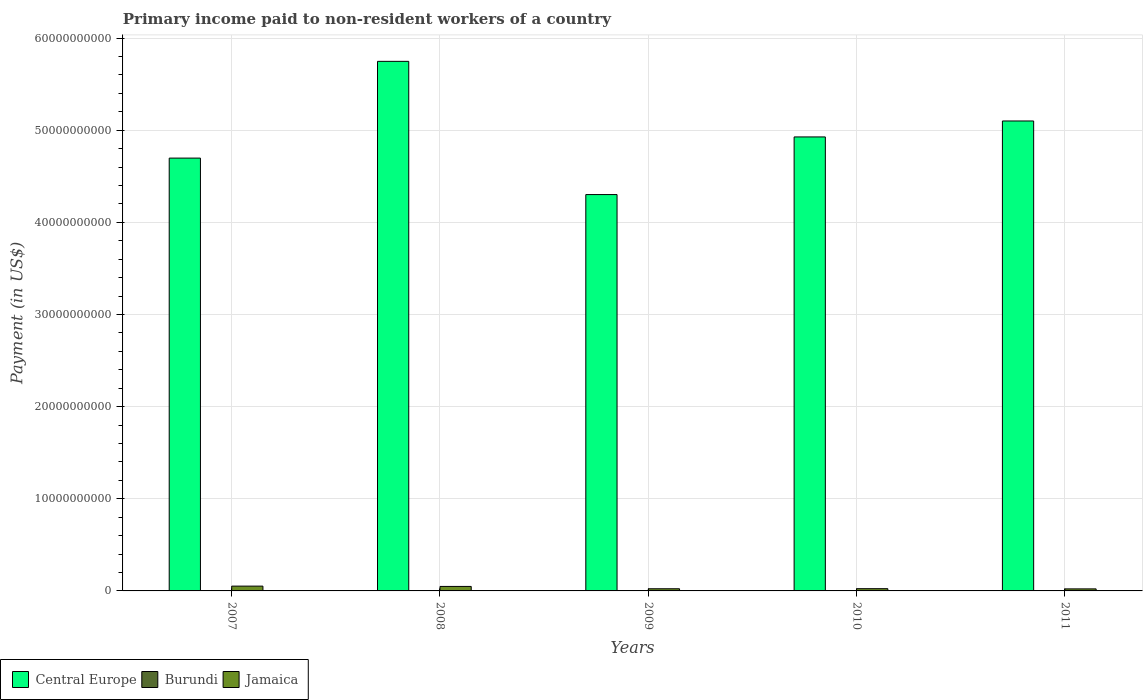How many different coloured bars are there?
Make the answer very short. 3. How many groups of bars are there?
Give a very brief answer. 5. Are the number of bars per tick equal to the number of legend labels?
Offer a terse response. Yes. Are the number of bars on each tick of the X-axis equal?
Your response must be concise. Yes. How many bars are there on the 5th tick from the left?
Offer a very short reply. 3. How many bars are there on the 4th tick from the right?
Give a very brief answer. 3. What is the amount paid to workers in Jamaica in 2010?
Ensure brevity in your answer.  2.43e+08. Across all years, what is the maximum amount paid to workers in Burundi?
Provide a succinct answer. 1.09e+07. Across all years, what is the minimum amount paid to workers in Central Europe?
Offer a terse response. 4.30e+1. What is the total amount paid to workers in Central Europe in the graph?
Offer a very short reply. 2.48e+11. What is the difference between the amount paid to workers in Jamaica in 2007 and that in 2011?
Keep it short and to the point. 2.99e+08. What is the difference between the amount paid to workers in Central Europe in 2007 and the amount paid to workers in Jamaica in 2009?
Keep it short and to the point. 4.67e+1. What is the average amount paid to workers in Burundi per year?
Give a very brief answer. 5.90e+06. In the year 2007, what is the difference between the amount paid to workers in Jamaica and amount paid to workers in Burundi?
Make the answer very short. 5.12e+08. In how many years, is the amount paid to workers in Jamaica greater than 22000000000 US$?
Your response must be concise. 0. What is the ratio of the amount paid to workers in Burundi in 2007 to that in 2011?
Ensure brevity in your answer.  1.16. Is the amount paid to workers in Central Europe in 2007 less than that in 2009?
Offer a very short reply. No. What is the difference between the highest and the second highest amount paid to workers in Jamaica?
Your answer should be compact. 3.28e+07. What is the difference between the highest and the lowest amount paid to workers in Central Europe?
Your answer should be compact. 1.45e+1. Is the sum of the amount paid to workers in Burundi in 2008 and 2009 greater than the maximum amount paid to workers in Central Europe across all years?
Offer a terse response. No. What does the 3rd bar from the left in 2011 represents?
Your answer should be compact. Jamaica. What does the 2nd bar from the right in 2010 represents?
Your answer should be very brief. Burundi. How many bars are there?
Provide a succinct answer. 15. Are all the bars in the graph horizontal?
Your answer should be compact. No. How many years are there in the graph?
Offer a very short reply. 5. What is the difference between two consecutive major ticks on the Y-axis?
Your response must be concise. 1.00e+1. Are the values on the major ticks of Y-axis written in scientific E-notation?
Offer a very short reply. No. Does the graph contain grids?
Your answer should be compact. Yes. How are the legend labels stacked?
Your answer should be very brief. Horizontal. What is the title of the graph?
Your answer should be compact. Primary income paid to non-resident workers of a country. Does "Turkey" appear as one of the legend labels in the graph?
Provide a succinct answer. No. What is the label or title of the X-axis?
Provide a succinct answer. Years. What is the label or title of the Y-axis?
Give a very brief answer. Payment (in US$). What is the Payment (in US$) in Central Europe in 2007?
Keep it short and to the point. 4.70e+1. What is the Payment (in US$) of Burundi in 2007?
Ensure brevity in your answer.  8.67e+06. What is the Payment (in US$) in Jamaica in 2007?
Provide a succinct answer. 5.21e+08. What is the Payment (in US$) in Central Europe in 2008?
Offer a terse response. 5.75e+1. What is the Payment (in US$) of Burundi in 2008?
Your response must be concise. 1.09e+07. What is the Payment (in US$) of Jamaica in 2008?
Your answer should be very brief. 4.88e+08. What is the Payment (in US$) of Central Europe in 2009?
Your answer should be compact. 4.30e+1. What is the Payment (in US$) of Burundi in 2009?
Your answer should be very brief. 1.38e+06. What is the Payment (in US$) of Jamaica in 2009?
Offer a terse response. 2.35e+08. What is the Payment (in US$) of Central Europe in 2010?
Your answer should be very brief. 4.93e+1. What is the Payment (in US$) in Burundi in 2010?
Your answer should be compact. 1.13e+06. What is the Payment (in US$) in Jamaica in 2010?
Give a very brief answer. 2.43e+08. What is the Payment (in US$) of Central Europe in 2011?
Keep it short and to the point. 5.10e+1. What is the Payment (in US$) in Burundi in 2011?
Make the answer very short. 7.46e+06. What is the Payment (in US$) in Jamaica in 2011?
Offer a very short reply. 2.21e+08. Across all years, what is the maximum Payment (in US$) in Central Europe?
Make the answer very short. 5.75e+1. Across all years, what is the maximum Payment (in US$) in Burundi?
Provide a succinct answer. 1.09e+07. Across all years, what is the maximum Payment (in US$) in Jamaica?
Your answer should be very brief. 5.21e+08. Across all years, what is the minimum Payment (in US$) of Central Europe?
Ensure brevity in your answer.  4.30e+1. Across all years, what is the minimum Payment (in US$) in Burundi?
Your answer should be very brief. 1.13e+06. Across all years, what is the minimum Payment (in US$) in Jamaica?
Provide a succinct answer. 2.21e+08. What is the total Payment (in US$) in Central Europe in the graph?
Provide a short and direct response. 2.48e+11. What is the total Payment (in US$) in Burundi in the graph?
Give a very brief answer. 2.95e+07. What is the total Payment (in US$) of Jamaica in the graph?
Your response must be concise. 1.71e+09. What is the difference between the Payment (in US$) of Central Europe in 2007 and that in 2008?
Your response must be concise. -1.05e+1. What is the difference between the Payment (in US$) in Burundi in 2007 and that in 2008?
Make the answer very short. -2.21e+06. What is the difference between the Payment (in US$) in Jamaica in 2007 and that in 2008?
Offer a very short reply. 3.28e+07. What is the difference between the Payment (in US$) in Central Europe in 2007 and that in 2009?
Your answer should be compact. 3.96e+09. What is the difference between the Payment (in US$) of Burundi in 2007 and that in 2009?
Provide a succinct answer. 7.29e+06. What is the difference between the Payment (in US$) in Jamaica in 2007 and that in 2009?
Your answer should be compact. 2.86e+08. What is the difference between the Payment (in US$) of Central Europe in 2007 and that in 2010?
Keep it short and to the point. -2.30e+09. What is the difference between the Payment (in US$) of Burundi in 2007 and that in 2010?
Make the answer very short. 7.54e+06. What is the difference between the Payment (in US$) of Jamaica in 2007 and that in 2010?
Your answer should be very brief. 2.78e+08. What is the difference between the Payment (in US$) of Central Europe in 2007 and that in 2011?
Offer a terse response. -4.03e+09. What is the difference between the Payment (in US$) in Burundi in 2007 and that in 2011?
Your answer should be compact. 1.21e+06. What is the difference between the Payment (in US$) of Jamaica in 2007 and that in 2011?
Make the answer very short. 2.99e+08. What is the difference between the Payment (in US$) of Central Europe in 2008 and that in 2009?
Keep it short and to the point. 1.45e+1. What is the difference between the Payment (in US$) in Burundi in 2008 and that in 2009?
Your response must be concise. 9.50e+06. What is the difference between the Payment (in US$) in Jamaica in 2008 and that in 2009?
Ensure brevity in your answer.  2.53e+08. What is the difference between the Payment (in US$) of Central Europe in 2008 and that in 2010?
Your response must be concise. 8.20e+09. What is the difference between the Payment (in US$) of Burundi in 2008 and that in 2010?
Make the answer very short. 9.75e+06. What is the difference between the Payment (in US$) in Jamaica in 2008 and that in 2010?
Provide a short and direct response. 2.45e+08. What is the difference between the Payment (in US$) in Central Europe in 2008 and that in 2011?
Your answer should be compact. 6.47e+09. What is the difference between the Payment (in US$) of Burundi in 2008 and that in 2011?
Offer a very short reply. 3.42e+06. What is the difference between the Payment (in US$) in Jamaica in 2008 and that in 2011?
Provide a short and direct response. 2.66e+08. What is the difference between the Payment (in US$) of Central Europe in 2009 and that in 2010?
Make the answer very short. -6.26e+09. What is the difference between the Payment (in US$) in Burundi in 2009 and that in 2010?
Provide a succinct answer. 2.46e+05. What is the difference between the Payment (in US$) in Jamaica in 2009 and that in 2010?
Offer a very short reply. -8.24e+06. What is the difference between the Payment (in US$) in Central Europe in 2009 and that in 2011?
Your response must be concise. -7.99e+09. What is the difference between the Payment (in US$) in Burundi in 2009 and that in 2011?
Provide a succinct answer. -6.09e+06. What is the difference between the Payment (in US$) of Jamaica in 2009 and that in 2011?
Your answer should be very brief. 1.35e+07. What is the difference between the Payment (in US$) in Central Europe in 2010 and that in 2011?
Your answer should be compact. -1.73e+09. What is the difference between the Payment (in US$) of Burundi in 2010 and that in 2011?
Provide a short and direct response. -6.33e+06. What is the difference between the Payment (in US$) in Jamaica in 2010 and that in 2011?
Provide a short and direct response. 2.17e+07. What is the difference between the Payment (in US$) of Central Europe in 2007 and the Payment (in US$) of Burundi in 2008?
Keep it short and to the point. 4.70e+1. What is the difference between the Payment (in US$) of Central Europe in 2007 and the Payment (in US$) of Jamaica in 2008?
Provide a succinct answer. 4.65e+1. What is the difference between the Payment (in US$) of Burundi in 2007 and the Payment (in US$) of Jamaica in 2008?
Make the answer very short. -4.79e+08. What is the difference between the Payment (in US$) in Central Europe in 2007 and the Payment (in US$) in Burundi in 2009?
Your response must be concise. 4.70e+1. What is the difference between the Payment (in US$) in Central Europe in 2007 and the Payment (in US$) in Jamaica in 2009?
Offer a very short reply. 4.67e+1. What is the difference between the Payment (in US$) in Burundi in 2007 and the Payment (in US$) in Jamaica in 2009?
Provide a short and direct response. -2.26e+08. What is the difference between the Payment (in US$) of Central Europe in 2007 and the Payment (in US$) of Burundi in 2010?
Keep it short and to the point. 4.70e+1. What is the difference between the Payment (in US$) of Central Europe in 2007 and the Payment (in US$) of Jamaica in 2010?
Give a very brief answer. 4.67e+1. What is the difference between the Payment (in US$) in Burundi in 2007 and the Payment (in US$) in Jamaica in 2010?
Provide a short and direct response. -2.35e+08. What is the difference between the Payment (in US$) of Central Europe in 2007 and the Payment (in US$) of Burundi in 2011?
Offer a very short reply. 4.70e+1. What is the difference between the Payment (in US$) in Central Europe in 2007 and the Payment (in US$) in Jamaica in 2011?
Provide a succinct answer. 4.68e+1. What is the difference between the Payment (in US$) of Burundi in 2007 and the Payment (in US$) of Jamaica in 2011?
Make the answer very short. -2.13e+08. What is the difference between the Payment (in US$) in Central Europe in 2008 and the Payment (in US$) in Burundi in 2009?
Ensure brevity in your answer.  5.75e+1. What is the difference between the Payment (in US$) of Central Europe in 2008 and the Payment (in US$) of Jamaica in 2009?
Your response must be concise. 5.72e+1. What is the difference between the Payment (in US$) in Burundi in 2008 and the Payment (in US$) in Jamaica in 2009?
Your response must be concise. -2.24e+08. What is the difference between the Payment (in US$) in Central Europe in 2008 and the Payment (in US$) in Burundi in 2010?
Give a very brief answer. 5.75e+1. What is the difference between the Payment (in US$) of Central Europe in 2008 and the Payment (in US$) of Jamaica in 2010?
Keep it short and to the point. 5.72e+1. What is the difference between the Payment (in US$) in Burundi in 2008 and the Payment (in US$) in Jamaica in 2010?
Ensure brevity in your answer.  -2.32e+08. What is the difference between the Payment (in US$) in Central Europe in 2008 and the Payment (in US$) in Burundi in 2011?
Provide a short and direct response. 5.75e+1. What is the difference between the Payment (in US$) of Central Europe in 2008 and the Payment (in US$) of Jamaica in 2011?
Keep it short and to the point. 5.73e+1. What is the difference between the Payment (in US$) in Burundi in 2008 and the Payment (in US$) in Jamaica in 2011?
Your answer should be very brief. -2.11e+08. What is the difference between the Payment (in US$) of Central Europe in 2009 and the Payment (in US$) of Burundi in 2010?
Give a very brief answer. 4.30e+1. What is the difference between the Payment (in US$) of Central Europe in 2009 and the Payment (in US$) of Jamaica in 2010?
Provide a short and direct response. 4.28e+1. What is the difference between the Payment (in US$) of Burundi in 2009 and the Payment (in US$) of Jamaica in 2010?
Your response must be concise. -2.42e+08. What is the difference between the Payment (in US$) in Central Europe in 2009 and the Payment (in US$) in Burundi in 2011?
Your response must be concise. 4.30e+1. What is the difference between the Payment (in US$) in Central Europe in 2009 and the Payment (in US$) in Jamaica in 2011?
Give a very brief answer. 4.28e+1. What is the difference between the Payment (in US$) in Burundi in 2009 and the Payment (in US$) in Jamaica in 2011?
Make the answer very short. -2.20e+08. What is the difference between the Payment (in US$) of Central Europe in 2010 and the Payment (in US$) of Burundi in 2011?
Offer a very short reply. 4.93e+1. What is the difference between the Payment (in US$) of Central Europe in 2010 and the Payment (in US$) of Jamaica in 2011?
Your response must be concise. 4.91e+1. What is the difference between the Payment (in US$) in Burundi in 2010 and the Payment (in US$) in Jamaica in 2011?
Ensure brevity in your answer.  -2.20e+08. What is the average Payment (in US$) of Central Europe per year?
Your answer should be compact. 4.96e+1. What is the average Payment (in US$) of Burundi per year?
Keep it short and to the point. 5.90e+06. What is the average Payment (in US$) in Jamaica per year?
Give a very brief answer. 3.42e+08. In the year 2007, what is the difference between the Payment (in US$) in Central Europe and Payment (in US$) in Burundi?
Your answer should be compact. 4.70e+1. In the year 2007, what is the difference between the Payment (in US$) of Central Europe and Payment (in US$) of Jamaica?
Provide a short and direct response. 4.65e+1. In the year 2007, what is the difference between the Payment (in US$) of Burundi and Payment (in US$) of Jamaica?
Your response must be concise. -5.12e+08. In the year 2008, what is the difference between the Payment (in US$) in Central Europe and Payment (in US$) in Burundi?
Your response must be concise. 5.75e+1. In the year 2008, what is the difference between the Payment (in US$) of Central Europe and Payment (in US$) of Jamaica?
Give a very brief answer. 5.70e+1. In the year 2008, what is the difference between the Payment (in US$) in Burundi and Payment (in US$) in Jamaica?
Ensure brevity in your answer.  -4.77e+08. In the year 2009, what is the difference between the Payment (in US$) of Central Europe and Payment (in US$) of Burundi?
Provide a succinct answer. 4.30e+1. In the year 2009, what is the difference between the Payment (in US$) in Central Europe and Payment (in US$) in Jamaica?
Keep it short and to the point. 4.28e+1. In the year 2009, what is the difference between the Payment (in US$) of Burundi and Payment (in US$) of Jamaica?
Your response must be concise. -2.34e+08. In the year 2010, what is the difference between the Payment (in US$) of Central Europe and Payment (in US$) of Burundi?
Give a very brief answer. 4.93e+1. In the year 2010, what is the difference between the Payment (in US$) in Central Europe and Payment (in US$) in Jamaica?
Provide a short and direct response. 4.90e+1. In the year 2010, what is the difference between the Payment (in US$) of Burundi and Payment (in US$) of Jamaica?
Provide a short and direct response. -2.42e+08. In the year 2011, what is the difference between the Payment (in US$) of Central Europe and Payment (in US$) of Burundi?
Your answer should be compact. 5.10e+1. In the year 2011, what is the difference between the Payment (in US$) of Central Europe and Payment (in US$) of Jamaica?
Ensure brevity in your answer.  5.08e+1. In the year 2011, what is the difference between the Payment (in US$) of Burundi and Payment (in US$) of Jamaica?
Provide a succinct answer. -2.14e+08. What is the ratio of the Payment (in US$) of Central Europe in 2007 to that in 2008?
Your answer should be compact. 0.82. What is the ratio of the Payment (in US$) in Burundi in 2007 to that in 2008?
Ensure brevity in your answer.  0.8. What is the ratio of the Payment (in US$) of Jamaica in 2007 to that in 2008?
Make the answer very short. 1.07. What is the ratio of the Payment (in US$) of Central Europe in 2007 to that in 2009?
Ensure brevity in your answer.  1.09. What is the ratio of the Payment (in US$) in Burundi in 2007 to that in 2009?
Make the answer very short. 6.3. What is the ratio of the Payment (in US$) of Jamaica in 2007 to that in 2009?
Keep it short and to the point. 2.22. What is the ratio of the Payment (in US$) of Central Europe in 2007 to that in 2010?
Your response must be concise. 0.95. What is the ratio of the Payment (in US$) in Burundi in 2007 to that in 2010?
Keep it short and to the point. 7.68. What is the ratio of the Payment (in US$) of Jamaica in 2007 to that in 2010?
Give a very brief answer. 2.14. What is the ratio of the Payment (in US$) of Central Europe in 2007 to that in 2011?
Your response must be concise. 0.92. What is the ratio of the Payment (in US$) of Burundi in 2007 to that in 2011?
Offer a very short reply. 1.16. What is the ratio of the Payment (in US$) of Jamaica in 2007 to that in 2011?
Your answer should be very brief. 2.35. What is the ratio of the Payment (in US$) in Central Europe in 2008 to that in 2009?
Offer a terse response. 1.34. What is the ratio of the Payment (in US$) in Burundi in 2008 to that in 2009?
Offer a terse response. 7.91. What is the ratio of the Payment (in US$) of Jamaica in 2008 to that in 2009?
Ensure brevity in your answer.  2.08. What is the ratio of the Payment (in US$) in Central Europe in 2008 to that in 2010?
Give a very brief answer. 1.17. What is the ratio of the Payment (in US$) of Burundi in 2008 to that in 2010?
Provide a succinct answer. 9.64. What is the ratio of the Payment (in US$) of Jamaica in 2008 to that in 2010?
Offer a very short reply. 2.01. What is the ratio of the Payment (in US$) of Central Europe in 2008 to that in 2011?
Provide a short and direct response. 1.13. What is the ratio of the Payment (in US$) in Burundi in 2008 to that in 2011?
Your response must be concise. 1.46. What is the ratio of the Payment (in US$) in Jamaica in 2008 to that in 2011?
Your answer should be very brief. 2.2. What is the ratio of the Payment (in US$) of Central Europe in 2009 to that in 2010?
Your answer should be very brief. 0.87. What is the ratio of the Payment (in US$) in Burundi in 2009 to that in 2010?
Ensure brevity in your answer.  1.22. What is the ratio of the Payment (in US$) of Jamaica in 2009 to that in 2010?
Keep it short and to the point. 0.97. What is the ratio of the Payment (in US$) in Central Europe in 2009 to that in 2011?
Offer a very short reply. 0.84. What is the ratio of the Payment (in US$) in Burundi in 2009 to that in 2011?
Ensure brevity in your answer.  0.18. What is the ratio of the Payment (in US$) of Jamaica in 2009 to that in 2011?
Offer a terse response. 1.06. What is the ratio of the Payment (in US$) in Central Europe in 2010 to that in 2011?
Give a very brief answer. 0.97. What is the ratio of the Payment (in US$) of Burundi in 2010 to that in 2011?
Your answer should be compact. 0.15. What is the ratio of the Payment (in US$) in Jamaica in 2010 to that in 2011?
Your answer should be very brief. 1.1. What is the difference between the highest and the second highest Payment (in US$) of Central Europe?
Your answer should be compact. 6.47e+09. What is the difference between the highest and the second highest Payment (in US$) in Burundi?
Give a very brief answer. 2.21e+06. What is the difference between the highest and the second highest Payment (in US$) in Jamaica?
Keep it short and to the point. 3.28e+07. What is the difference between the highest and the lowest Payment (in US$) in Central Europe?
Give a very brief answer. 1.45e+1. What is the difference between the highest and the lowest Payment (in US$) in Burundi?
Offer a very short reply. 9.75e+06. What is the difference between the highest and the lowest Payment (in US$) of Jamaica?
Make the answer very short. 2.99e+08. 